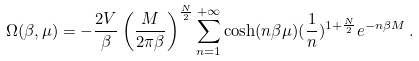Convert formula to latex. <formula><loc_0><loc_0><loc_500><loc_500>\Omega ( \beta , \mu ) = - { \frac { 2 V } { \beta } } \left ( { \frac { M } { 2 \pi \beta } } \right ) ^ { \frac { N } { 2 } } \sum _ { n = 1 } ^ { + \infty } \cosh ( n \beta \mu ) ( { \frac { 1 } { n } } ) ^ { 1 + { \frac { N } { 2 } } } e ^ { - n \beta M } \, .</formula> 